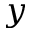Convert formula to latex. <formula><loc_0><loc_0><loc_500><loc_500>y</formula> 